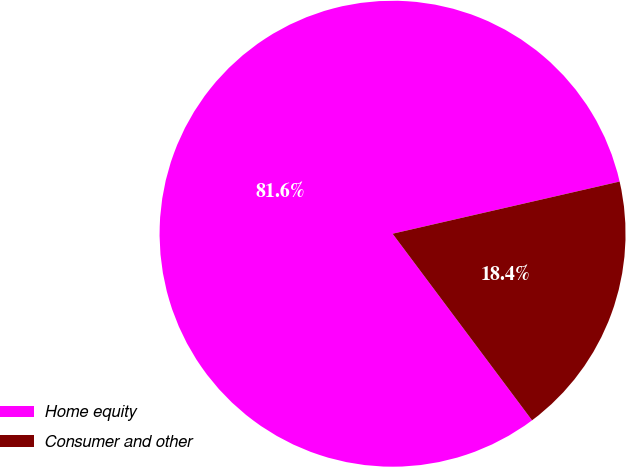Convert chart. <chart><loc_0><loc_0><loc_500><loc_500><pie_chart><fcel>Home equity<fcel>Consumer and other<nl><fcel>81.62%<fcel>18.38%<nl></chart> 